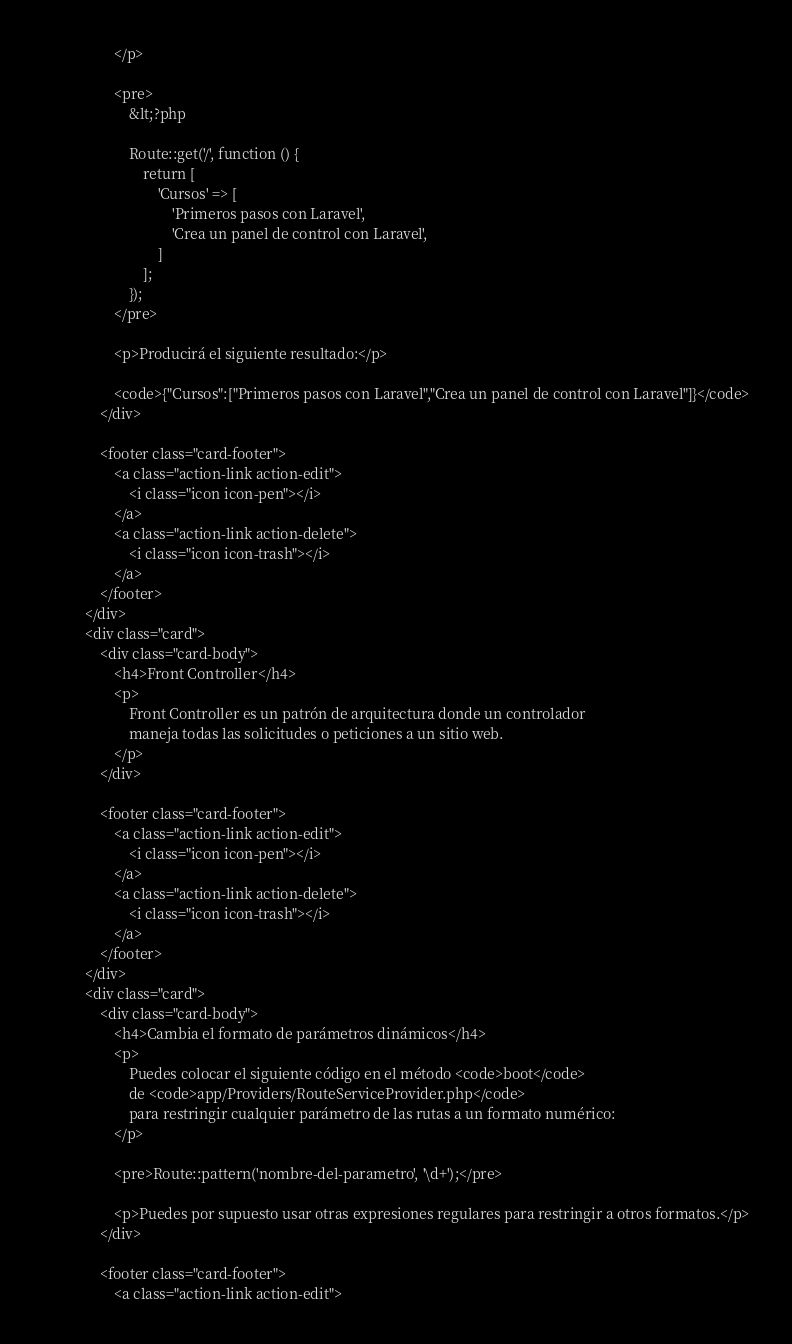<code> <loc_0><loc_0><loc_500><loc_500><_PHP_>                    </p>

                    <pre>
                        &lt;?php

                        Route::get('/', function () {
                            return [
                                'Cursos' => [
                                    'Primeros pasos con Laravel',
                                    'Crea un panel de control con Laravel',
                                ]
                            ];
                        });
                    </pre>

                    <p>Producirá el siguiente resultado:</p>

                    <code>{"Cursos":["Primeros pasos con Laravel","Crea un panel de control con Laravel"]}</code>
                </div>

                <footer class="card-footer">
                    <a class="action-link action-edit">
                        <i class="icon icon-pen"></i>
                    </a>
                    <a class="action-link action-delete">
                        <i class="icon icon-trash"></i>
                    </a>
                </footer>
            </div>
            <div class="card">
                <div class="card-body">
                    <h4>Front Controller</h4>
                    <p>
                        Front Controller es un patrón de arquitectura donde un controlador
                        maneja todas las solicitudes o peticiones a un sitio web.
                    </p>
                </div>

                <footer class="card-footer">
                    <a class="action-link action-edit">
                        <i class="icon icon-pen"></i>
                    </a>
                    <a class="action-link action-delete">
                        <i class="icon icon-trash"></i>
                    </a>
                </footer>
            </div>
            <div class="card">
                <div class="card-body">
                    <h4>Cambia el formato de parámetros dinámicos</h4>
                    <p>
                        Puedes colocar el siguiente código en el método <code>boot</code>
                        de <code>app/Providers/RouteServiceProvider.php</code>
                        para restringir cualquier parámetro de las rutas a un formato numérico:
                    </p>

                    <pre>Route::pattern('nombre-del-parametro', '\d+');</pre>

                    <p>Puedes por supuesto usar otras expresiones regulares para restringir a otros formatos.</p>
                </div>

                <footer class="card-footer">
                    <a class="action-link action-edit"></code> 